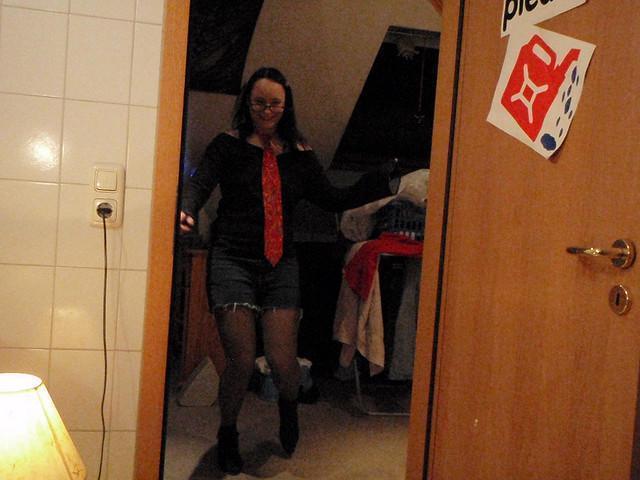How many zebra near from tree?
Give a very brief answer. 0. 